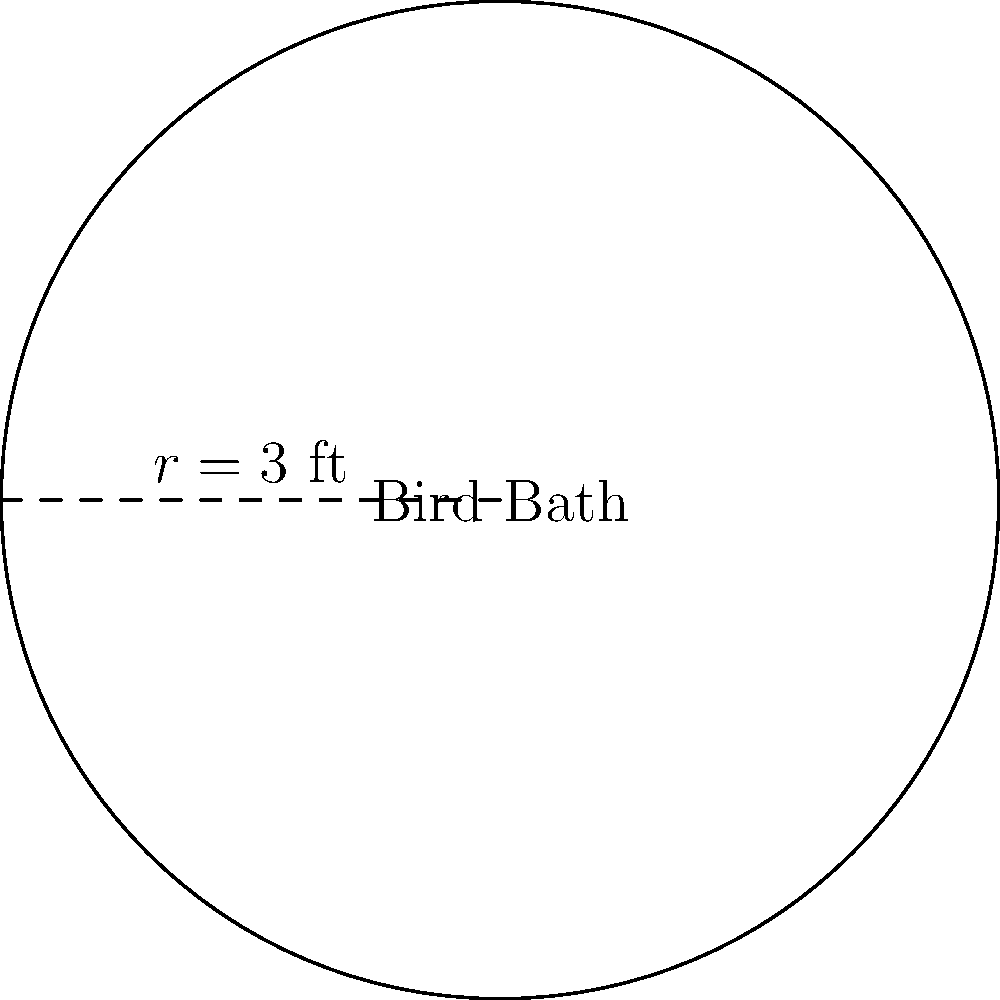As a bird enthusiast, you've decided to install a circular bird bath in your backyard to attract more feathered visitors. The bird bath has a radius of 3 feet. What is the area of the water surface in square feet? To find the area of the circular bird bath, we need to use the formula for the area of a circle:

$$A = \pi r^2$$

Where:
$A$ = area of the circle
$\pi$ = pi (approximately 3.14159)
$r$ = radius of the circle

Given:
$r = 3$ feet

Let's substitute the values into the formula:

$$A = \pi (3)^2$$
$$A = \pi (9)$$
$$A = 9\pi$$

To get the numerical value, we can use 3.14159 as an approximation for $\pi$:

$$A \approx 9 \times 3.14159$$
$$A \approx 28.27431 \text{ square feet}$$

Rounding to two decimal places:
$$A \approx 28.27 \text{ square feet}$$
Answer: $28.27 \text{ ft}^2$ 